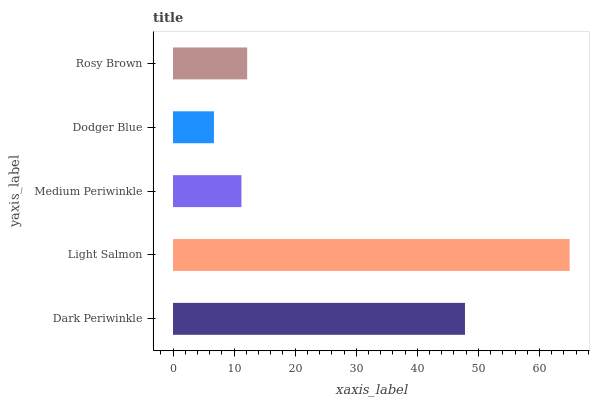Is Dodger Blue the minimum?
Answer yes or no. Yes. Is Light Salmon the maximum?
Answer yes or no. Yes. Is Medium Periwinkle the minimum?
Answer yes or no. No. Is Medium Periwinkle the maximum?
Answer yes or no. No. Is Light Salmon greater than Medium Periwinkle?
Answer yes or no. Yes. Is Medium Periwinkle less than Light Salmon?
Answer yes or no. Yes. Is Medium Periwinkle greater than Light Salmon?
Answer yes or no. No. Is Light Salmon less than Medium Periwinkle?
Answer yes or no. No. Is Rosy Brown the high median?
Answer yes or no. Yes. Is Rosy Brown the low median?
Answer yes or no. Yes. Is Dodger Blue the high median?
Answer yes or no. No. Is Dodger Blue the low median?
Answer yes or no. No. 